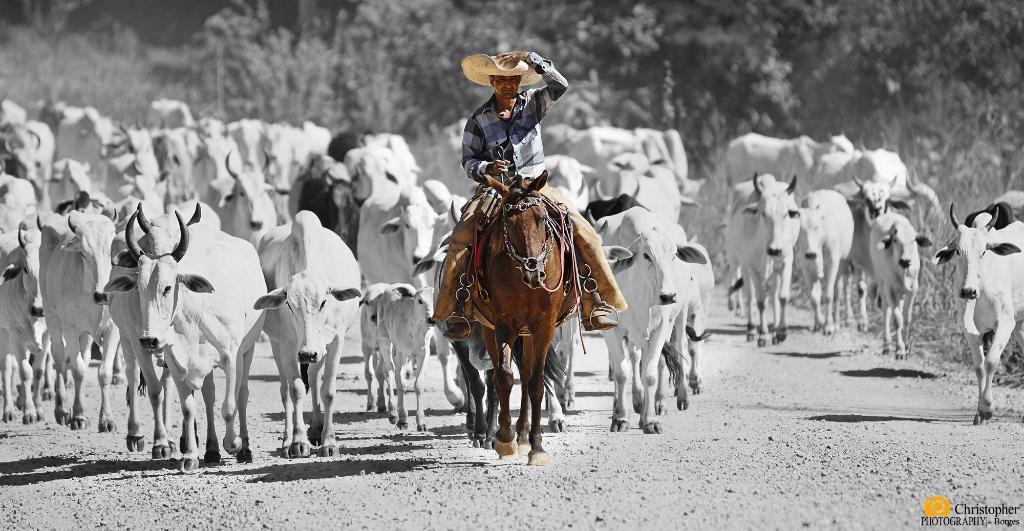How would you summarize this image in a sentence or two? In the center of the image we can see that the person riding on the horse. In the background there are many cows and trees. 